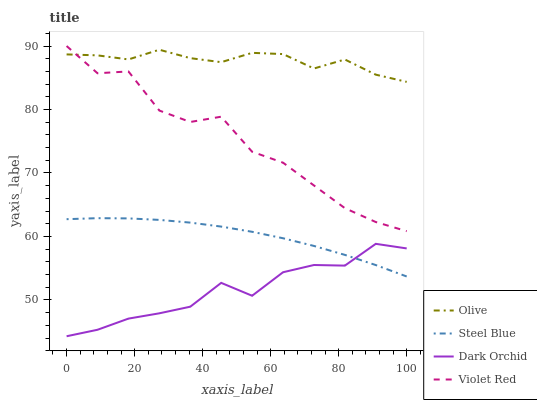Does Dark Orchid have the minimum area under the curve?
Answer yes or no. Yes. Does Olive have the maximum area under the curve?
Answer yes or no. Yes. Does Violet Red have the minimum area under the curve?
Answer yes or no. No. Does Violet Red have the maximum area under the curve?
Answer yes or no. No. Is Steel Blue the smoothest?
Answer yes or no. Yes. Is Violet Red the roughest?
Answer yes or no. Yes. Is Violet Red the smoothest?
Answer yes or no. No. Is Steel Blue the roughest?
Answer yes or no. No. Does Dark Orchid have the lowest value?
Answer yes or no. Yes. Does Violet Red have the lowest value?
Answer yes or no. No. Does Violet Red have the highest value?
Answer yes or no. Yes. Does Steel Blue have the highest value?
Answer yes or no. No. Is Dark Orchid less than Olive?
Answer yes or no. Yes. Is Violet Red greater than Dark Orchid?
Answer yes or no. Yes. Does Violet Red intersect Olive?
Answer yes or no. Yes. Is Violet Red less than Olive?
Answer yes or no. No. Is Violet Red greater than Olive?
Answer yes or no. No. Does Dark Orchid intersect Olive?
Answer yes or no. No. 